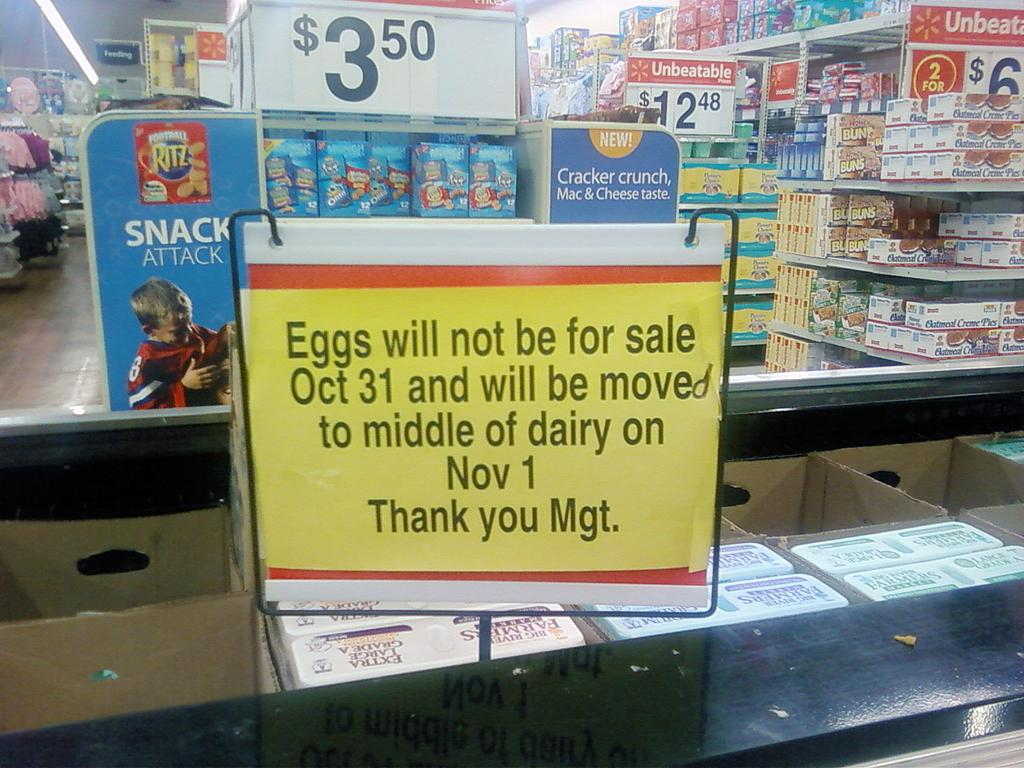<image>
Render a clear and concise summary of the photo. A sign in a store indicating that eggs will not be on sale on Oct. 31 and will be moved to Nov. 1st. 